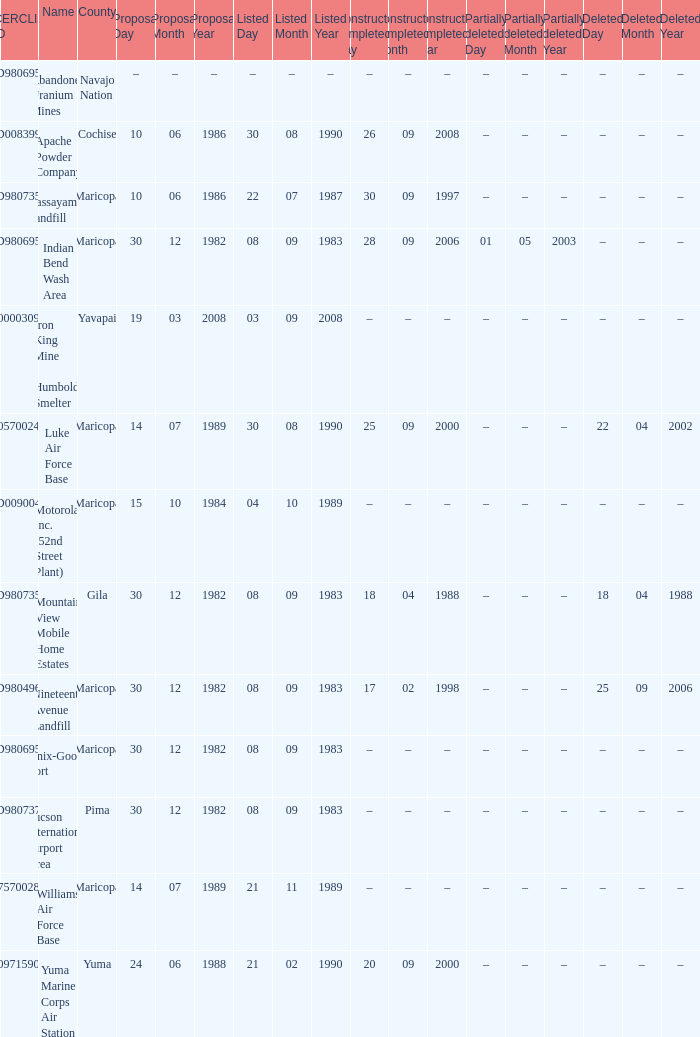When was the site partially deleted when the cerclis id is az7570028582? –. 